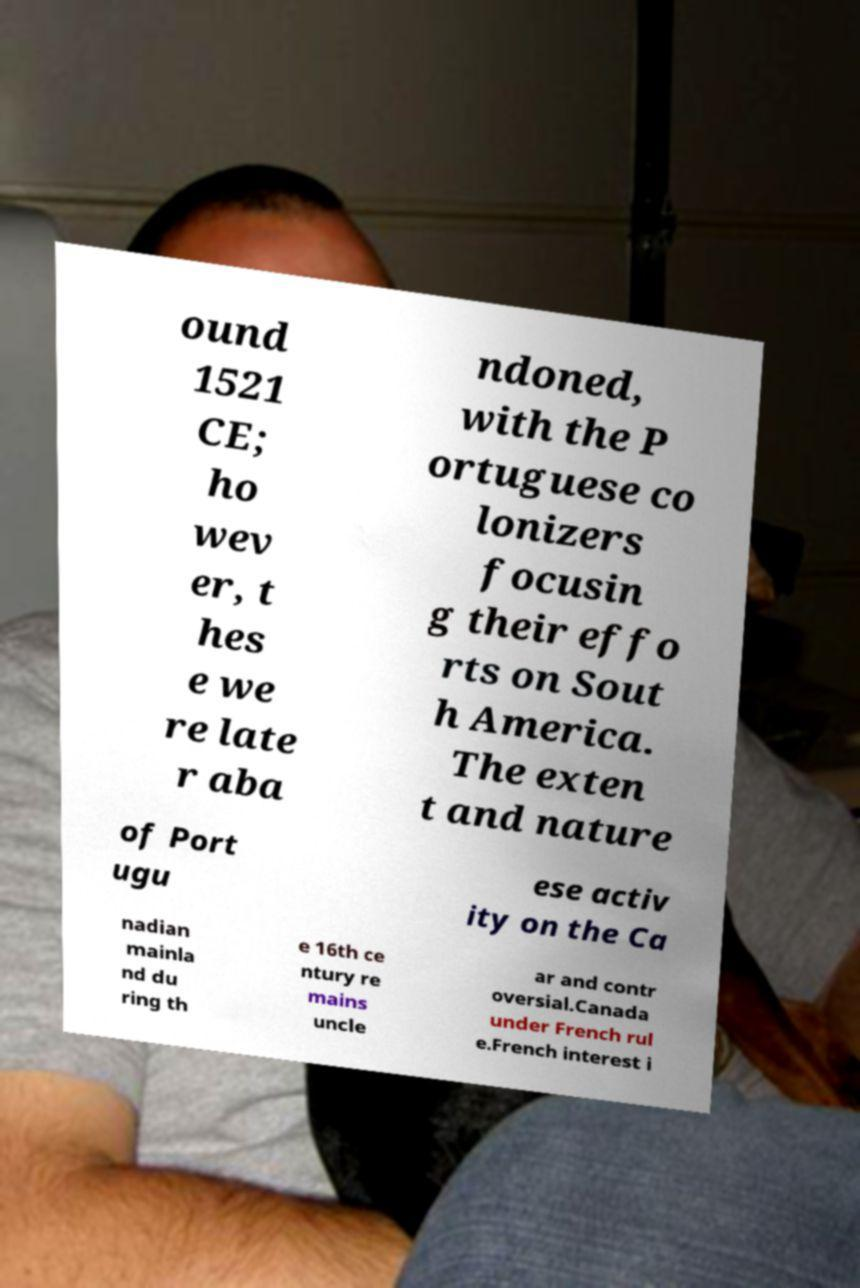Please identify and transcribe the text found in this image. ound 1521 CE; ho wev er, t hes e we re late r aba ndoned, with the P ortuguese co lonizers focusin g their effo rts on Sout h America. The exten t and nature of Port ugu ese activ ity on the Ca nadian mainla nd du ring th e 16th ce ntury re mains uncle ar and contr oversial.Canada under French rul e.French interest i 